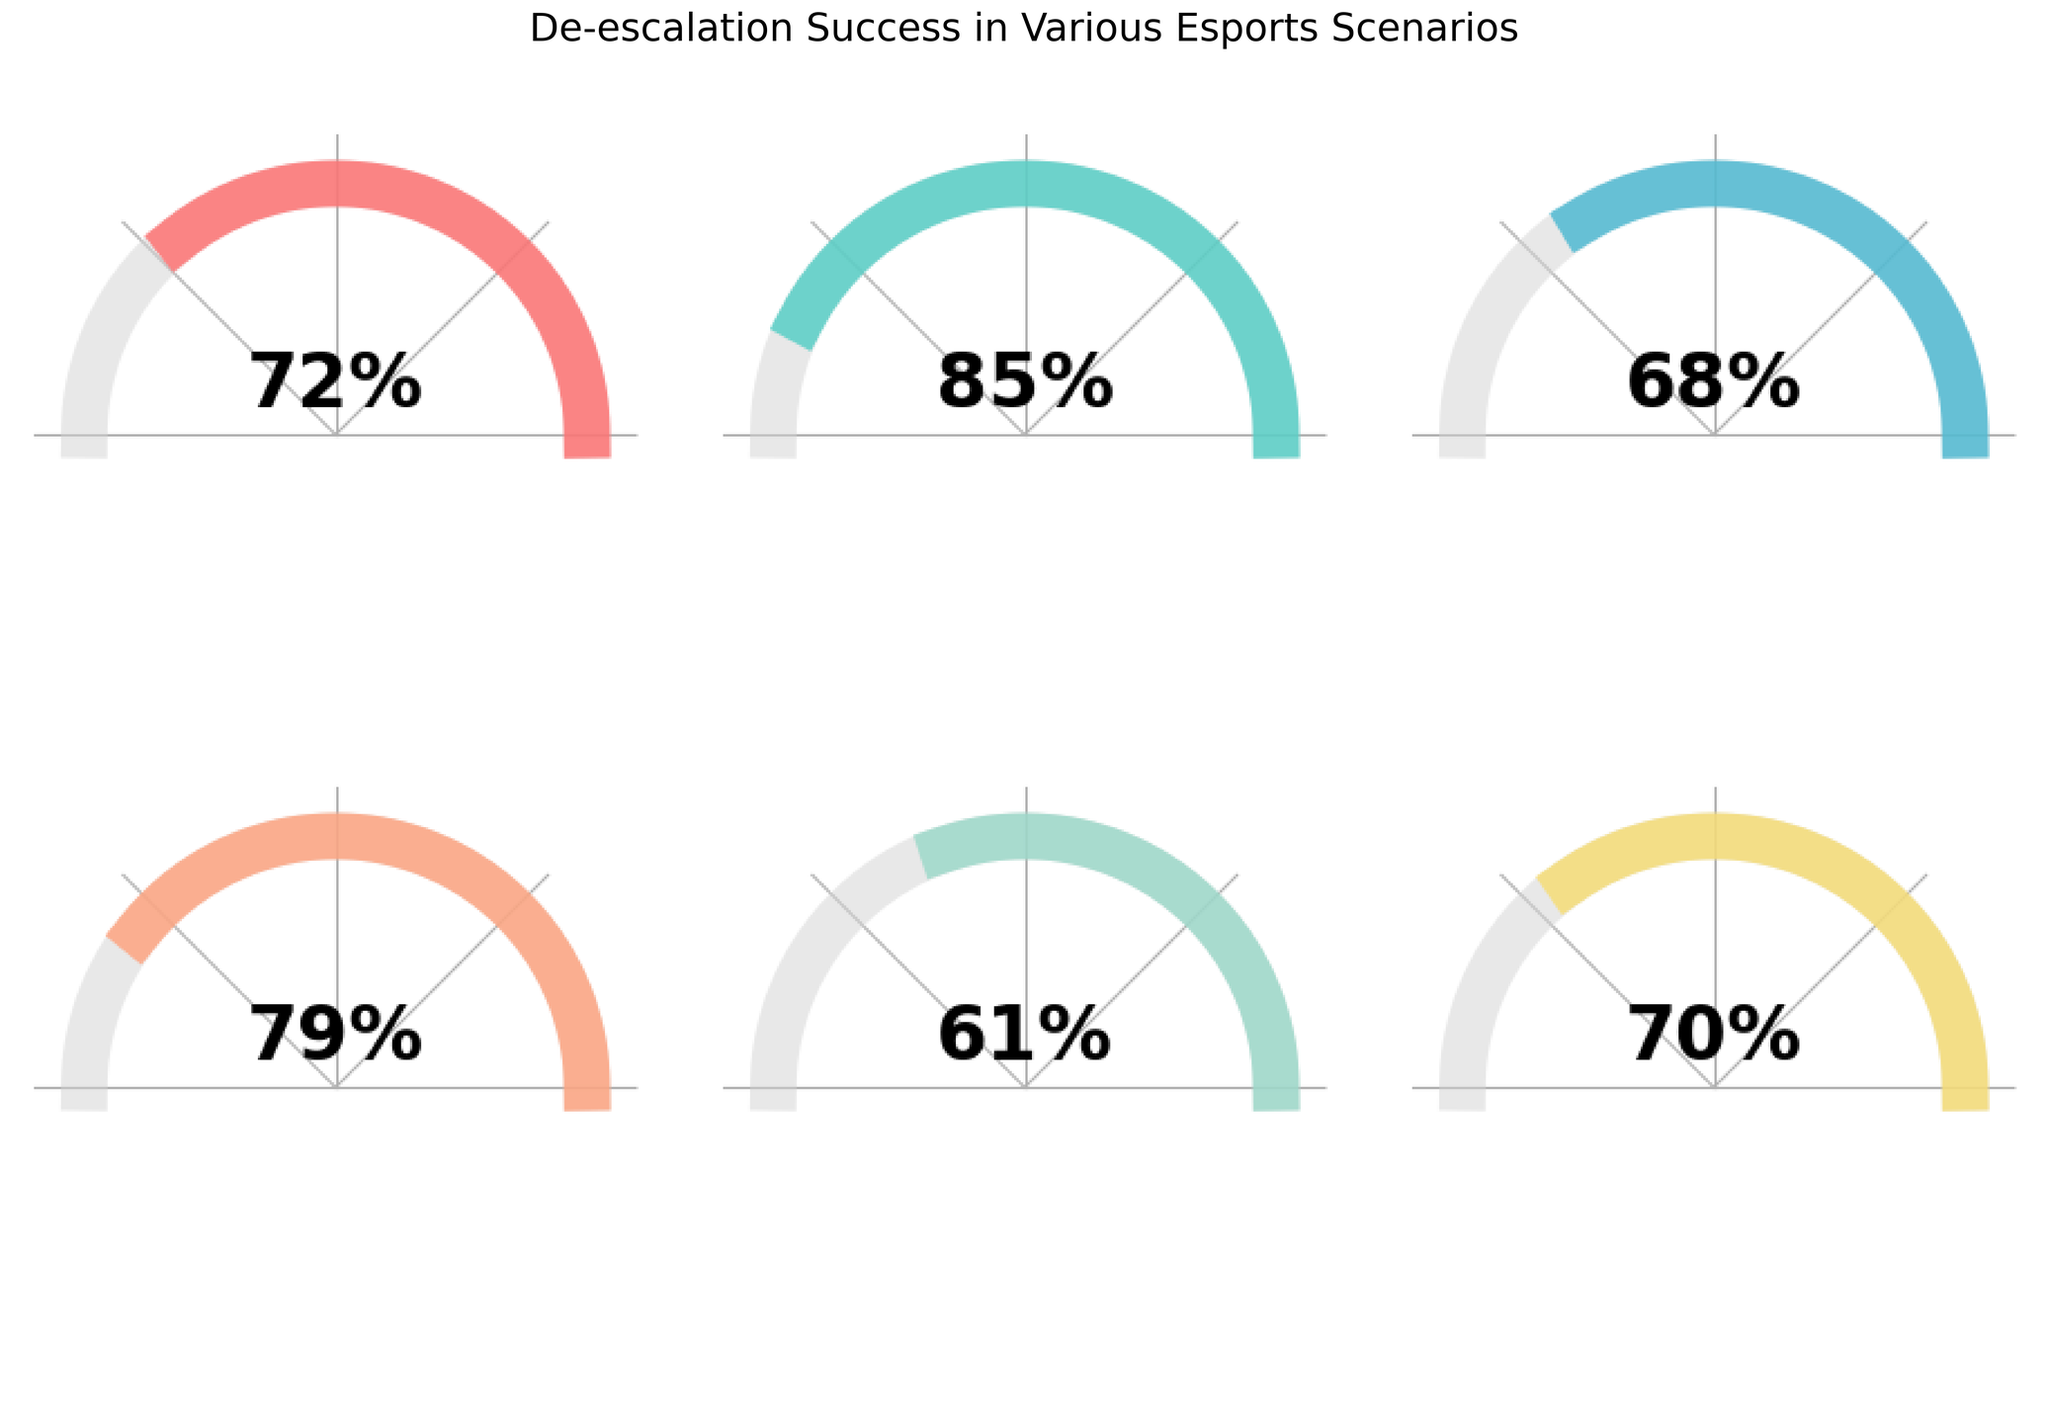Which category has the highest percentage of de-escalation success? The gauge chart for "Verbal Confrontations" shows an 85% success rate, which is the highest among all categories.
Answer: Verbal Confrontations Which category has the lowest percentage of de-escalation success? The chart representing "Post-Match Disputes" indicates a 61% success rate, which is the lowest among the categories presented.
Answer: Post-Match Disputes What is the average percentage of de-escalation success across all categories? Add the percentages (72 + 85 + 68 + 79 + 61 + 70) and divide by the number of categories (6): (72+85+68+79+61+70)/6 = 435/6 = 72.5%
Answer: 72.5% How much higher is the de-escalation success rate for "Verbal Confrontations" compared to "In-Game Trash Talk"? Subtract the percentage for "In-Game Trash Talk" from the percentage for "Verbal Confrontations": 85% - 68% = 17%
Answer: 17% Which categories have a de-escalation success rate above 70%? The categories with success rates above 70% are "Overall De-escalation Success" (72%), "Verbal Confrontations" (85%), "Team Infighting" (79%), and "Tournament Pressure Situations" (70%).
Answer: Overall De-escalation Success, Verbal Confrontations, Team Infighting, Tournament Pressure Situations Is the success rate for "Team Infighting" above or below 80%? The chart shows "Team Infighting" has a success rate of 79%, which is below 80%.
Answer: Below What is the difference in de-escalation success rates between "Post-Match Disputes" and "Overall De-escalation Success"? Subtract the percentage for "Post-Match Disputes" from the percentage for "Overall De-escalation Success": 72% - 61% = 11%
Answer: 11% What is the median de-escalation success rate among the categories? To find the median, first list the percentages in ascending order: 61, 68, 70, 72, 79, 85. The median is the average of the two middle values: (70 + 72)/2 = 71%.
Answer: 71% How does the de-escalation success rate for "Tournament Pressure Situations" compare to the "Overall De-escalation Success" rate? Both categories have success rates that are close, with "Tournament Pressure Situations" at 70% and "Overall De-escalation Success" at 72%, making the difference 2%.
Answer: 2% lower 